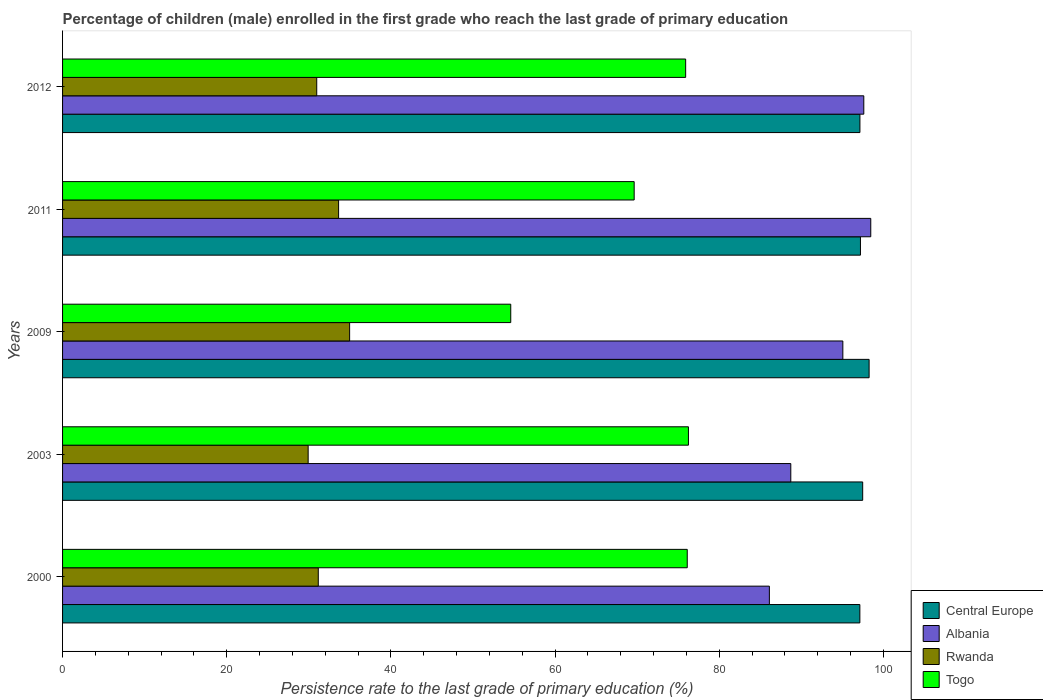How many groups of bars are there?
Offer a very short reply. 5. Are the number of bars on each tick of the Y-axis equal?
Give a very brief answer. Yes. What is the persistence rate of children in Rwanda in 2009?
Offer a terse response. 34.97. Across all years, what is the maximum persistence rate of children in Central Europe?
Keep it short and to the point. 98.27. Across all years, what is the minimum persistence rate of children in Rwanda?
Give a very brief answer. 29.92. In which year was the persistence rate of children in Central Europe minimum?
Offer a terse response. 2000. What is the total persistence rate of children in Albania in the graph?
Ensure brevity in your answer.  465.99. What is the difference between the persistence rate of children in Togo in 2003 and that in 2009?
Ensure brevity in your answer.  21.65. What is the difference between the persistence rate of children in Rwanda in 2009 and the persistence rate of children in Central Europe in 2000?
Provide a short and direct response. -62.17. What is the average persistence rate of children in Albania per year?
Your answer should be very brief. 93.2. In the year 2000, what is the difference between the persistence rate of children in Albania and persistence rate of children in Central Europe?
Your answer should be very brief. -11.03. In how many years, is the persistence rate of children in Togo greater than 52 %?
Ensure brevity in your answer.  5. What is the ratio of the persistence rate of children in Togo in 2000 to that in 2011?
Offer a very short reply. 1.09. Is the difference between the persistence rate of children in Albania in 2000 and 2012 greater than the difference between the persistence rate of children in Central Europe in 2000 and 2012?
Ensure brevity in your answer.  No. What is the difference between the highest and the second highest persistence rate of children in Rwanda?
Ensure brevity in your answer.  1.34. What is the difference between the highest and the lowest persistence rate of children in Rwanda?
Keep it short and to the point. 5.05. In how many years, is the persistence rate of children in Central Europe greater than the average persistence rate of children in Central Europe taken over all years?
Your response must be concise. 2. Is it the case that in every year, the sum of the persistence rate of children in Albania and persistence rate of children in Rwanda is greater than the sum of persistence rate of children in Central Europe and persistence rate of children in Togo?
Your answer should be very brief. No. What does the 2nd bar from the top in 2003 represents?
Your answer should be compact. Rwanda. What does the 1st bar from the bottom in 2012 represents?
Make the answer very short. Central Europe. How many bars are there?
Offer a very short reply. 20. Does the graph contain any zero values?
Make the answer very short. No. Does the graph contain grids?
Offer a terse response. No. How many legend labels are there?
Offer a very short reply. 4. How are the legend labels stacked?
Provide a short and direct response. Vertical. What is the title of the graph?
Offer a very short reply. Percentage of children (male) enrolled in the first grade who reach the last grade of primary education. Does "Papua New Guinea" appear as one of the legend labels in the graph?
Your answer should be very brief. No. What is the label or title of the X-axis?
Keep it short and to the point. Persistence rate to the last grade of primary education (%). What is the Persistence rate to the last grade of primary education (%) in Central Europe in 2000?
Offer a terse response. 97.14. What is the Persistence rate to the last grade of primary education (%) in Albania in 2000?
Offer a very short reply. 86.11. What is the Persistence rate to the last grade of primary education (%) in Rwanda in 2000?
Offer a terse response. 31.16. What is the Persistence rate to the last grade of primary education (%) of Togo in 2000?
Make the answer very short. 76.11. What is the Persistence rate to the last grade of primary education (%) in Central Europe in 2003?
Give a very brief answer. 97.48. What is the Persistence rate to the last grade of primary education (%) in Albania in 2003?
Give a very brief answer. 88.73. What is the Persistence rate to the last grade of primary education (%) in Rwanda in 2003?
Keep it short and to the point. 29.92. What is the Persistence rate to the last grade of primary education (%) of Togo in 2003?
Keep it short and to the point. 76.25. What is the Persistence rate to the last grade of primary education (%) in Central Europe in 2009?
Provide a short and direct response. 98.27. What is the Persistence rate to the last grade of primary education (%) of Albania in 2009?
Offer a terse response. 95.07. What is the Persistence rate to the last grade of primary education (%) in Rwanda in 2009?
Offer a terse response. 34.97. What is the Persistence rate to the last grade of primary education (%) of Togo in 2009?
Your response must be concise. 54.61. What is the Persistence rate to the last grade of primary education (%) in Central Europe in 2011?
Ensure brevity in your answer.  97.21. What is the Persistence rate to the last grade of primary education (%) in Albania in 2011?
Ensure brevity in your answer.  98.47. What is the Persistence rate to the last grade of primary education (%) in Rwanda in 2011?
Your response must be concise. 33.63. What is the Persistence rate to the last grade of primary education (%) in Togo in 2011?
Offer a terse response. 69.64. What is the Persistence rate to the last grade of primary education (%) in Central Europe in 2012?
Your response must be concise. 97.15. What is the Persistence rate to the last grade of primary education (%) in Albania in 2012?
Offer a terse response. 97.62. What is the Persistence rate to the last grade of primary education (%) of Rwanda in 2012?
Keep it short and to the point. 30.97. What is the Persistence rate to the last grade of primary education (%) of Togo in 2012?
Provide a short and direct response. 75.91. Across all years, what is the maximum Persistence rate to the last grade of primary education (%) in Central Europe?
Provide a succinct answer. 98.27. Across all years, what is the maximum Persistence rate to the last grade of primary education (%) in Albania?
Offer a very short reply. 98.47. Across all years, what is the maximum Persistence rate to the last grade of primary education (%) of Rwanda?
Your response must be concise. 34.97. Across all years, what is the maximum Persistence rate to the last grade of primary education (%) of Togo?
Offer a terse response. 76.25. Across all years, what is the minimum Persistence rate to the last grade of primary education (%) in Central Europe?
Your answer should be very brief. 97.14. Across all years, what is the minimum Persistence rate to the last grade of primary education (%) in Albania?
Make the answer very short. 86.11. Across all years, what is the minimum Persistence rate to the last grade of primary education (%) in Rwanda?
Give a very brief answer. 29.92. Across all years, what is the minimum Persistence rate to the last grade of primary education (%) in Togo?
Give a very brief answer. 54.61. What is the total Persistence rate to the last grade of primary education (%) of Central Europe in the graph?
Keep it short and to the point. 487.25. What is the total Persistence rate to the last grade of primary education (%) in Albania in the graph?
Provide a short and direct response. 465.99. What is the total Persistence rate to the last grade of primary education (%) of Rwanda in the graph?
Keep it short and to the point. 160.65. What is the total Persistence rate to the last grade of primary education (%) in Togo in the graph?
Ensure brevity in your answer.  352.53. What is the difference between the Persistence rate to the last grade of primary education (%) in Central Europe in 2000 and that in 2003?
Make the answer very short. -0.34. What is the difference between the Persistence rate to the last grade of primary education (%) in Albania in 2000 and that in 2003?
Keep it short and to the point. -2.61. What is the difference between the Persistence rate to the last grade of primary education (%) of Rwanda in 2000 and that in 2003?
Your answer should be very brief. 1.23. What is the difference between the Persistence rate to the last grade of primary education (%) in Togo in 2000 and that in 2003?
Offer a very short reply. -0.15. What is the difference between the Persistence rate to the last grade of primary education (%) in Central Europe in 2000 and that in 2009?
Give a very brief answer. -1.13. What is the difference between the Persistence rate to the last grade of primary education (%) in Albania in 2000 and that in 2009?
Ensure brevity in your answer.  -8.95. What is the difference between the Persistence rate to the last grade of primary education (%) of Rwanda in 2000 and that in 2009?
Offer a very short reply. -3.82. What is the difference between the Persistence rate to the last grade of primary education (%) in Togo in 2000 and that in 2009?
Ensure brevity in your answer.  21.5. What is the difference between the Persistence rate to the last grade of primary education (%) of Central Europe in 2000 and that in 2011?
Provide a succinct answer. -0.07. What is the difference between the Persistence rate to the last grade of primary education (%) of Albania in 2000 and that in 2011?
Provide a short and direct response. -12.35. What is the difference between the Persistence rate to the last grade of primary education (%) of Rwanda in 2000 and that in 2011?
Offer a very short reply. -2.47. What is the difference between the Persistence rate to the last grade of primary education (%) of Togo in 2000 and that in 2011?
Make the answer very short. 6.47. What is the difference between the Persistence rate to the last grade of primary education (%) in Central Europe in 2000 and that in 2012?
Offer a very short reply. -0.01. What is the difference between the Persistence rate to the last grade of primary education (%) in Albania in 2000 and that in 2012?
Your answer should be compact. -11.5. What is the difference between the Persistence rate to the last grade of primary education (%) in Rwanda in 2000 and that in 2012?
Offer a very short reply. 0.19. What is the difference between the Persistence rate to the last grade of primary education (%) of Togo in 2000 and that in 2012?
Make the answer very short. 0.19. What is the difference between the Persistence rate to the last grade of primary education (%) in Central Europe in 2003 and that in 2009?
Provide a short and direct response. -0.78. What is the difference between the Persistence rate to the last grade of primary education (%) of Albania in 2003 and that in 2009?
Offer a very short reply. -6.34. What is the difference between the Persistence rate to the last grade of primary education (%) of Rwanda in 2003 and that in 2009?
Give a very brief answer. -5.05. What is the difference between the Persistence rate to the last grade of primary education (%) in Togo in 2003 and that in 2009?
Your answer should be compact. 21.65. What is the difference between the Persistence rate to the last grade of primary education (%) in Central Europe in 2003 and that in 2011?
Keep it short and to the point. 0.27. What is the difference between the Persistence rate to the last grade of primary education (%) in Albania in 2003 and that in 2011?
Give a very brief answer. -9.74. What is the difference between the Persistence rate to the last grade of primary education (%) of Rwanda in 2003 and that in 2011?
Offer a terse response. -3.71. What is the difference between the Persistence rate to the last grade of primary education (%) of Togo in 2003 and that in 2011?
Provide a succinct answer. 6.61. What is the difference between the Persistence rate to the last grade of primary education (%) in Central Europe in 2003 and that in 2012?
Make the answer very short. 0.34. What is the difference between the Persistence rate to the last grade of primary education (%) of Albania in 2003 and that in 2012?
Provide a succinct answer. -8.89. What is the difference between the Persistence rate to the last grade of primary education (%) in Rwanda in 2003 and that in 2012?
Ensure brevity in your answer.  -1.04. What is the difference between the Persistence rate to the last grade of primary education (%) in Togo in 2003 and that in 2012?
Make the answer very short. 0.34. What is the difference between the Persistence rate to the last grade of primary education (%) in Central Europe in 2009 and that in 2011?
Keep it short and to the point. 1.05. What is the difference between the Persistence rate to the last grade of primary education (%) in Albania in 2009 and that in 2011?
Offer a very short reply. -3.4. What is the difference between the Persistence rate to the last grade of primary education (%) in Rwanda in 2009 and that in 2011?
Ensure brevity in your answer.  1.34. What is the difference between the Persistence rate to the last grade of primary education (%) of Togo in 2009 and that in 2011?
Provide a short and direct response. -15.04. What is the difference between the Persistence rate to the last grade of primary education (%) of Central Europe in 2009 and that in 2012?
Keep it short and to the point. 1.12. What is the difference between the Persistence rate to the last grade of primary education (%) in Albania in 2009 and that in 2012?
Offer a very short reply. -2.55. What is the difference between the Persistence rate to the last grade of primary education (%) in Rwanda in 2009 and that in 2012?
Provide a short and direct response. 4.01. What is the difference between the Persistence rate to the last grade of primary education (%) of Togo in 2009 and that in 2012?
Your answer should be very brief. -21.31. What is the difference between the Persistence rate to the last grade of primary education (%) of Central Europe in 2011 and that in 2012?
Your answer should be compact. 0.06. What is the difference between the Persistence rate to the last grade of primary education (%) in Albania in 2011 and that in 2012?
Offer a very short reply. 0.85. What is the difference between the Persistence rate to the last grade of primary education (%) of Rwanda in 2011 and that in 2012?
Offer a very short reply. 2.66. What is the difference between the Persistence rate to the last grade of primary education (%) in Togo in 2011 and that in 2012?
Give a very brief answer. -6.27. What is the difference between the Persistence rate to the last grade of primary education (%) in Central Europe in 2000 and the Persistence rate to the last grade of primary education (%) in Albania in 2003?
Ensure brevity in your answer.  8.42. What is the difference between the Persistence rate to the last grade of primary education (%) of Central Europe in 2000 and the Persistence rate to the last grade of primary education (%) of Rwanda in 2003?
Provide a succinct answer. 67.22. What is the difference between the Persistence rate to the last grade of primary education (%) in Central Europe in 2000 and the Persistence rate to the last grade of primary education (%) in Togo in 2003?
Keep it short and to the point. 20.89. What is the difference between the Persistence rate to the last grade of primary education (%) in Albania in 2000 and the Persistence rate to the last grade of primary education (%) in Rwanda in 2003?
Ensure brevity in your answer.  56.19. What is the difference between the Persistence rate to the last grade of primary education (%) in Albania in 2000 and the Persistence rate to the last grade of primary education (%) in Togo in 2003?
Make the answer very short. 9.86. What is the difference between the Persistence rate to the last grade of primary education (%) in Rwanda in 2000 and the Persistence rate to the last grade of primary education (%) in Togo in 2003?
Ensure brevity in your answer.  -45.1. What is the difference between the Persistence rate to the last grade of primary education (%) of Central Europe in 2000 and the Persistence rate to the last grade of primary education (%) of Albania in 2009?
Make the answer very short. 2.07. What is the difference between the Persistence rate to the last grade of primary education (%) of Central Europe in 2000 and the Persistence rate to the last grade of primary education (%) of Rwanda in 2009?
Offer a very short reply. 62.17. What is the difference between the Persistence rate to the last grade of primary education (%) of Central Europe in 2000 and the Persistence rate to the last grade of primary education (%) of Togo in 2009?
Your response must be concise. 42.53. What is the difference between the Persistence rate to the last grade of primary education (%) in Albania in 2000 and the Persistence rate to the last grade of primary education (%) in Rwanda in 2009?
Your response must be concise. 51.14. What is the difference between the Persistence rate to the last grade of primary education (%) of Albania in 2000 and the Persistence rate to the last grade of primary education (%) of Togo in 2009?
Provide a short and direct response. 31.51. What is the difference between the Persistence rate to the last grade of primary education (%) of Rwanda in 2000 and the Persistence rate to the last grade of primary education (%) of Togo in 2009?
Provide a succinct answer. -23.45. What is the difference between the Persistence rate to the last grade of primary education (%) in Central Europe in 2000 and the Persistence rate to the last grade of primary education (%) in Albania in 2011?
Provide a short and direct response. -1.33. What is the difference between the Persistence rate to the last grade of primary education (%) in Central Europe in 2000 and the Persistence rate to the last grade of primary education (%) in Rwanda in 2011?
Provide a short and direct response. 63.51. What is the difference between the Persistence rate to the last grade of primary education (%) of Central Europe in 2000 and the Persistence rate to the last grade of primary education (%) of Togo in 2011?
Your answer should be very brief. 27.5. What is the difference between the Persistence rate to the last grade of primary education (%) of Albania in 2000 and the Persistence rate to the last grade of primary education (%) of Rwanda in 2011?
Keep it short and to the point. 52.48. What is the difference between the Persistence rate to the last grade of primary education (%) of Albania in 2000 and the Persistence rate to the last grade of primary education (%) of Togo in 2011?
Offer a terse response. 16.47. What is the difference between the Persistence rate to the last grade of primary education (%) of Rwanda in 2000 and the Persistence rate to the last grade of primary education (%) of Togo in 2011?
Keep it short and to the point. -38.49. What is the difference between the Persistence rate to the last grade of primary education (%) of Central Europe in 2000 and the Persistence rate to the last grade of primary education (%) of Albania in 2012?
Offer a very short reply. -0.48. What is the difference between the Persistence rate to the last grade of primary education (%) of Central Europe in 2000 and the Persistence rate to the last grade of primary education (%) of Rwanda in 2012?
Your answer should be very brief. 66.17. What is the difference between the Persistence rate to the last grade of primary education (%) of Central Europe in 2000 and the Persistence rate to the last grade of primary education (%) of Togo in 2012?
Provide a succinct answer. 21.23. What is the difference between the Persistence rate to the last grade of primary education (%) in Albania in 2000 and the Persistence rate to the last grade of primary education (%) in Rwanda in 2012?
Your response must be concise. 55.15. What is the difference between the Persistence rate to the last grade of primary education (%) in Albania in 2000 and the Persistence rate to the last grade of primary education (%) in Togo in 2012?
Your answer should be very brief. 10.2. What is the difference between the Persistence rate to the last grade of primary education (%) of Rwanda in 2000 and the Persistence rate to the last grade of primary education (%) of Togo in 2012?
Provide a succinct answer. -44.76. What is the difference between the Persistence rate to the last grade of primary education (%) in Central Europe in 2003 and the Persistence rate to the last grade of primary education (%) in Albania in 2009?
Keep it short and to the point. 2.42. What is the difference between the Persistence rate to the last grade of primary education (%) of Central Europe in 2003 and the Persistence rate to the last grade of primary education (%) of Rwanda in 2009?
Offer a very short reply. 62.51. What is the difference between the Persistence rate to the last grade of primary education (%) of Central Europe in 2003 and the Persistence rate to the last grade of primary education (%) of Togo in 2009?
Keep it short and to the point. 42.88. What is the difference between the Persistence rate to the last grade of primary education (%) of Albania in 2003 and the Persistence rate to the last grade of primary education (%) of Rwanda in 2009?
Keep it short and to the point. 53.75. What is the difference between the Persistence rate to the last grade of primary education (%) in Albania in 2003 and the Persistence rate to the last grade of primary education (%) in Togo in 2009?
Make the answer very short. 34.12. What is the difference between the Persistence rate to the last grade of primary education (%) of Rwanda in 2003 and the Persistence rate to the last grade of primary education (%) of Togo in 2009?
Give a very brief answer. -24.68. What is the difference between the Persistence rate to the last grade of primary education (%) in Central Europe in 2003 and the Persistence rate to the last grade of primary education (%) in Albania in 2011?
Your answer should be very brief. -0.98. What is the difference between the Persistence rate to the last grade of primary education (%) of Central Europe in 2003 and the Persistence rate to the last grade of primary education (%) of Rwanda in 2011?
Offer a terse response. 63.85. What is the difference between the Persistence rate to the last grade of primary education (%) of Central Europe in 2003 and the Persistence rate to the last grade of primary education (%) of Togo in 2011?
Offer a terse response. 27.84. What is the difference between the Persistence rate to the last grade of primary education (%) in Albania in 2003 and the Persistence rate to the last grade of primary education (%) in Rwanda in 2011?
Ensure brevity in your answer.  55.09. What is the difference between the Persistence rate to the last grade of primary education (%) in Albania in 2003 and the Persistence rate to the last grade of primary education (%) in Togo in 2011?
Ensure brevity in your answer.  19.08. What is the difference between the Persistence rate to the last grade of primary education (%) in Rwanda in 2003 and the Persistence rate to the last grade of primary education (%) in Togo in 2011?
Your response must be concise. -39.72. What is the difference between the Persistence rate to the last grade of primary education (%) in Central Europe in 2003 and the Persistence rate to the last grade of primary education (%) in Albania in 2012?
Ensure brevity in your answer.  -0.13. What is the difference between the Persistence rate to the last grade of primary education (%) of Central Europe in 2003 and the Persistence rate to the last grade of primary education (%) of Rwanda in 2012?
Provide a short and direct response. 66.52. What is the difference between the Persistence rate to the last grade of primary education (%) in Central Europe in 2003 and the Persistence rate to the last grade of primary education (%) in Togo in 2012?
Keep it short and to the point. 21.57. What is the difference between the Persistence rate to the last grade of primary education (%) of Albania in 2003 and the Persistence rate to the last grade of primary education (%) of Rwanda in 2012?
Offer a terse response. 57.76. What is the difference between the Persistence rate to the last grade of primary education (%) in Albania in 2003 and the Persistence rate to the last grade of primary education (%) in Togo in 2012?
Ensure brevity in your answer.  12.81. What is the difference between the Persistence rate to the last grade of primary education (%) in Rwanda in 2003 and the Persistence rate to the last grade of primary education (%) in Togo in 2012?
Give a very brief answer. -45.99. What is the difference between the Persistence rate to the last grade of primary education (%) of Central Europe in 2009 and the Persistence rate to the last grade of primary education (%) of Albania in 2011?
Your answer should be very brief. -0.2. What is the difference between the Persistence rate to the last grade of primary education (%) in Central Europe in 2009 and the Persistence rate to the last grade of primary education (%) in Rwanda in 2011?
Give a very brief answer. 64.64. What is the difference between the Persistence rate to the last grade of primary education (%) of Central Europe in 2009 and the Persistence rate to the last grade of primary education (%) of Togo in 2011?
Offer a very short reply. 28.62. What is the difference between the Persistence rate to the last grade of primary education (%) in Albania in 2009 and the Persistence rate to the last grade of primary education (%) in Rwanda in 2011?
Offer a very short reply. 61.43. What is the difference between the Persistence rate to the last grade of primary education (%) of Albania in 2009 and the Persistence rate to the last grade of primary education (%) of Togo in 2011?
Offer a terse response. 25.42. What is the difference between the Persistence rate to the last grade of primary education (%) of Rwanda in 2009 and the Persistence rate to the last grade of primary education (%) of Togo in 2011?
Ensure brevity in your answer.  -34.67. What is the difference between the Persistence rate to the last grade of primary education (%) in Central Europe in 2009 and the Persistence rate to the last grade of primary education (%) in Albania in 2012?
Your response must be concise. 0.65. What is the difference between the Persistence rate to the last grade of primary education (%) of Central Europe in 2009 and the Persistence rate to the last grade of primary education (%) of Rwanda in 2012?
Keep it short and to the point. 67.3. What is the difference between the Persistence rate to the last grade of primary education (%) in Central Europe in 2009 and the Persistence rate to the last grade of primary education (%) in Togo in 2012?
Provide a short and direct response. 22.35. What is the difference between the Persistence rate to the last grade of primary education (%) in Albania in 2009 and the Persistence rate to the last grade of primary education (%) in Rwanda in 2012?
Provide a succinct answer. 64.1. What is the difference between the Persistence rate to the last grade of primary education (%) in Albania in 2009 and the Persistence rate to the last grade of primary education (%) in Togo in 2012?
Provide a short and direct response. 19.15. What is the difference between the Persistence rate to the last grade of primary education (%) in Rwanda in 2009 and the Persistence rate to the last grade of primary education (%) in Togo in 2012?
Offer a terse response. -40.94. What is the difference between the Persistence rate to the last grade of primary education (%) of Central Europe in 2011 and the Persistence rate to the last grade of primary education (%) of Albania in 2012?
Your response must be concise. -0.41. What is the difference between the Persistence rate to the last grade of primary education (%) in Central Europe in 2011 and the Persistence rate to the last grade of primary education (%) in Rwanda in 2012?
Your response must be concise. 66.24. What is the difference between the Persistence rate to the last grade of primary education (%) of Central Europe in 2011 and the Persistence rate to the last grade of primary education (%) of Togo in 2012?
Your response must be concise. 21.3. What is the difference between the Persistence rate to the last grade of primary education (%) of Albania in 2011 and the Persistence rate to the last grade of primary education (%) of Rwanda in 2012?
Ensure brevity in your answer.  67.5. What is the difference between the Persistence rate to the last grade of primary education (%) in Albania in 2011 and the Persistence rate to the last grade of primary education (%) in Togo in 2012?
Your response must be concise. 22.55. What is the difference between the Persistence rate to the last grade of primary education (%) in Rwanda in 2011 and the Persistence rate to the last grade of primary education (%) in Togo in 2012?
Your answer should be very brief. -42.28. What is the average Persistence rate to the last grade of primary education (%) in Central Europe per year?
Your answer should be very brief. 97.45. What is the average Persistence rate to the last grade of primary education (%) of Albania per year?
Offer a terse response. 93.2. What is the average Persistence rate to the last grade of primary education (%) in Rwanda per year?
Offer a very short reply. 32.13. What is the average Persistence rate to the last grade of primary education (%) of Togo per year?
Offer a terse response. 70.51. In the year 2000, what is the difference between the Persistence rate to the last grade of primary education (%) of Central Europe and Persistence rate to the last grade of primary education (%) of Albania?
Provide a short and direct response. 11.03. In the year 2000, what is the difference between the Persistence rate to the last grade of primary education (%) of Central Europe and Persistence rate to the last grade of primary education (%) of Rwanda?
Your answer should be compact. 65.98. In the year 2000, what is the difference between the Persistence rate to the last grade of primary education (%) in Central Europe and Persistence rate to the last grade of primary education (%) in Togo?
Give a very brief answer. 21.03. In the year 2000, what is the difference between the Persistence rate to the last grade of primary education (%) in Albania and Persistence rate to the last grade of primary education (%) in Rwanda?
Offer a terse response. 54.96. In the year 2000, what is the difference between the Persistence rate to the last grade of primary education (%) of Albania and Persistence rate to the last grade of primary education (%) of Togo?
Make the answer very short. 10.01. In the year 2000, what is the difference between the Persistence rate to the last grade of primary education (%) of Rwanda and Persistence rate to the last grade of primary education (%) of Togo?
Provide a succinct answer. -44.95. In the year 2003, what is the difference between the Persistence rate to the last grade of primary education (%) in Central Europe and Persistence rate to the last grade of primary education (%) in Albania?
Offer a very short reply. 8.76. In the year 2003, what is the difference between the Persistence rate to the last grade of primary education (%) in Central Europe and Persistence rate to the last grade of primary education (%) in Rwanda?
Keep it short and to the point. 67.56. In the year 2003, what is the difference between the Persistence rate to the last grade of primary education (%) in Central Europe and Persistence rate to the last grade of primary education (%) in Togo?
Offer a terse response. 21.23. In the year 2003, what is the difference between the Persistence rate to the last grade of primary education (%) of Albania and Persistence rate to the last grade of primary education (%) of Rwanda?
Offer a terse response. 58.8. In the year 2003, what is the difference between the Persistence rate to the last grade of primary education (%) of Albania and Persistence rate to the last grade of primary education (%) of Togo?
Your response must be concise. 12.47. In the year 2003, what is the difference between the Persistence rate to the last grade of primary education (%) of Rwanda and Persistence rate to the last grade of primary education (%) of Togo?
Your answer should be very brief. -46.33. In the year 2009, what is the difference between the Persistence rate to the last grade of primary education (%) of Central Europe and Persistence rate to the last grade of primary education (%) of Albania?
Your response must be concise. 3.2. In the year 2009, what is the difference between the Persistence rate to the last grade of primary education (%) of Central Europe and Persistence rate to the last grade of primary education (%) of Rwanda?
Give a very brief answer. 63.29. In the year 2009, what is the difference between the Persistence rate to the last grade of primary education (%) of Central Europe and Persistence rate to the last grade of primary education (%) of Togo?
Keep it short and to the point. 43.66. In the year 2009, what is the difference between the Persistence rate to the last grade of primary education (%) of Albania and Persistence rate to the last grade of primary education (%) of Rwanda?
Your answer should be very brief. 60.09. In the year 2009, what is the difference between the Persistence rate to the last grade of primary education (%) in Albania and Persistence rate to the last grade of primary education (%) in Togo?
Your answer should be compact. 40.46. In the year 2009, what is the difference between the Persistence rate to the last grade of primary education (%) in Rwanda and Persistence rate to the last grade of primary education (%) in Togo?
Offer a very short reply. -19.63. In the year 2011, what is the difference between the Persistence rate to the last grade of primary education (%) of Central Europe and Persistence rate to the last grade of primary education (%) of Albania?
Give a very brief answer. -1.26. In the year 2011, what is the difference between the Persistence rate to the last grade of primary education (%) of Central Europe and Persistence rate to the last grade of primary education (%) of Rwanda?
Provide a succinct answer. 63.58. In the year 2011, what is the difference between the Persistence rate to the last grade of primary education (%) in Central Europe and Persistence rate to the last grade of primary education (%) in Togo?
Offer a very short reply. 27.57. In the year 2011, what is the difference between the Persistence rate to the last grade of primary education (%) in Albania and Persistence rate to the last grade of primary education (%) in Rwanda?
Your response must be concise. 64.84. In the year 2011, what is the difference between the Persistence rate to the last grade of primary education (%) of Albania and Persistence rate to the last grade of primary education (%) of Togo?
Keep it short and to the point. 28.83. In the year 2011, what is the difference between the Persistence rate to the last grade of primary education (%) in Rwanda and Persistence rate to the last grade of primary education (%) in Togo?
Offer a very short reply. -36.01. In the year 2012, what is the difference between the Persistence rate to the last grade of primary education (%) in Central Europe and Persistence rate to the last grade of primary education (%) in Albania?
Your answer should be very brief. -0.47. In the year 2012, what is the difference between the Persistence rate to the last grade of primary education (%) of Central Europe and Persistence rate to the last grade of primary education (%) of Rwanda?
Make the answer very short. 66.18. In the year 2012, what is the difference between the Persistence rate to the last grade of primary education (%) in Central Europe and Persistence rate to the last grade of primary education (%) in Togo?
Offer a terse response. 21.23. In the year 2012, what is the difference between the Persistence rate to the last grade of primary education (%) of Albania and Persistence rate to the last grade of primary education (%) of Rwanda?
Offer a terse response. 66.65. In the year 2012, what is the difference between the Persistence rate to the last grade of primary education (%) in Albania and Persistence rate to the last grade of primary education (%) in Togo?
Offer a terse response. 21.7. In the year 2012, what is the difference between the Persistence rate to the last grade of primary education (%) in Rwanda and Persistence rate to the last grade of primary education (%) in Togo?
Give a very brief answer. -44.95. What is the ratio of the Persistence rate to the last grade of primary education (%) in Central Europe in 2000 to that in 2003?
Keep it short and to the point. 1. What is the ratio of the Persistence rate to the last grade of primary education (%) in Albania in 2000 to that in 2003?
Make the answer very short. 0.97. What is the ratio of the Persistence rate to the last grade of primary education (%) of Rwanda in 2000 to that in 2003?
Your response must be concise. 1.04. What is the ratio of the Persistence rate to the last grade of primary education (%) in Togo in 2000 to that in 2003?
Provide a short and direct response. 1. What is the ratio of the Persistence rate to the last grade of primary education (%) of Albania in 2000 to that in 2009?
Make the answer very short. 0.91. What is the ratio of the Persistence rate to the last grade of primary education (%) in Rwanda in 2000 to that in 2009?
Offer a terse response. 0.89. What is the ratio of the Persistence rate to the last grade of primary education (%) of Togo in 2000 to that in 2009?
Ensure brevity in your answer.  1.39. What is the ratio of the Persistence rate to the last grade of primary education (%) of Albania in 2000 to that in 2011?
Offer a terse response. 0.87. What is the ratio of the Persistence rate to the last grade of primary education (%) of Rwanda in 2000 to that in 2011?
Make the answer very short. 0.93. What is the ratio of the Persistence rate to the last grade of primary education (%) of Togo in 2000 to that in 2011?
Provide a short and direct response. 1.09. What is the ratio of the Persistence rate to the last grade of primary education (%) in Central Europe in 2000 to that in 2012?
Make the answer very short. 1. What is the ratio of the Persistence rate to the last grade of primary education (%) of Albania in 2000 to that in 2012?
Keep it short and to the point. 0.88. What is the ratio of the Persistence rate to the last grade of primary education (%) of Rwanda in 2000 to that in 2012?
Keep it short and to the point. 1.01. What is the ratio of the Persistence rate to the last grade of primary education (%) of Togo in 2000 to that in 2012?
Your answer should be very brief. 1. What is the ratio of the Persistence rate to the last grade of primary education (%) in Central Europe in 2003 to that in 2009?
Your answer should be very brief. 0.99. What is the ratio of the Persistence rate to the last grade of primary education (%) in Rwanda in 2003 to that in 2009?
Offer a terse response. 0.86. What is the ratio of the Persistence rate to the last grade of primary education (%) in Togo in 2003 to that in 2009?
Your answer should be very brief. 1.4. What is the ratio of the Persistence rate to the last grade of primary education (%) in Albania in 2003 to that in 2011?
Ensure brevity in your answer.  0.9. What is the ratio of the Persistence rate to the last grade of primary education (%) of Rwanda in 2003 to that in 2011?
Provide a succinct answer. 0.89. What is the ratio of the Persistence rate to the last grade of primary education (%) in Togo in 2003 to that in 2011?
Make the answer very short. 1.09. What is the ratio of the Persistence rate to the last grade of primary education (%) in Albania in 2003 to that in 2012?
Your answer should be very brief. 0.91. What is the ratio of the Persistence rate to the last grade of primary education (%) in Rwanda in 2003 to that in 2012?
Offer a terse response. 0.97. What is the ratio of the Persistence rate to the last grade of primary education (%) of Central Europe in 2009 to that in 2011?
Offer a terse response. 1.01. What is the ratio of the Persistence rate to the last grade of primary education (%) in Albania in 2009 to that in 2011?
Your response must be concise. 0.97. What is the ratio of the Persistence rate to the last grade of primary education (%) of Rwanda in 2009 to that in 2011?
Your answer should be compact. 1.04. What is the ratio of the Persistence rate to the last grade of primary education (%) in Togo in 2009 to that in 2011?
Give a very brief answer. 0.78. What is the ratio of the Persistence rate to the last grade of primary education (%) in Central Europe in 2009 to that in 2012?
Your answer should be compact. 1.01. What is the ratio of the Persistence rate to the last grade of primary education (%) of Albania in 2009 to that in 2012?
Your answer should be very brief. 0.97. What is the ratio of the Persistence rate to the last grade of primary education (%) of Rwanda in 2009 to that in 2012?
Provide a short and direct response. 1.13. What is the ratio of the Persistence rate to the last grade of primary education (%) of Togo in 2009 to that in 2012?
Your answer should be compact. 0.72. What is the ratio of the Persistence rate to the last grade of primary education (%) of Albania in 2011 to that in 2012?
Keep it short and to the point. 1.01. What is the ratio of the Persistence rate to the last grade of primary education (%) in Rwanda in 2011 to that in 2012?
Your answer should be very brief. 1.09. What is the ratio of the Persistence rate to the last grade of primary education (%) of Togo in 2011 to that in 2012?
Make the answer very short. 0.92. What is the difference between the highest and the second highest Persistence rate to the last grade of primary education (%) of Central Europe?
Provide a short and direct response. 0.78. What is the difference between the highest and the second highest Persistence rate to the last grade of primary education (%) in Albania?
Your answer should be very brief. 0.85. What is the difference between the highest and the second highest Persistence rate to the last grade of primary education (%) in Rwanda?
Offer a very short reply. 1.34. What is the difference between the highest and the second highest Persistence rate to the last grade of primary education (%) of Togo?
Make the answer very short. 0.15. What is the difference between the highest and the lowest Persistence rate to the last grade of primary education (%) of Central Europe?
Offer a terse response. 1.13. What is the difference between the highest and the lowest Persistence rate to the last grade of primary education (%) of Albania?
Provide a succinct answer. 12.35. What is the difference between the highest and the lowest Persistence rate to the last grade of primary education (%) of Rwanda?
Offer a terse response. 5.05. What is the difference between the highest and the lowest Persistence rate to the last grade of primary education (%) in Togo?
Offer a terse response. 21.65. 